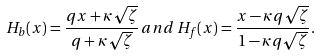Convert formula to latex. <formula><loc_0><loc_0><loc_500><loc_500>H _ { b } ( x ) = \frac { q x + \kappa \sqrt { \zeta } } { q + \kappa \sqrt { \zeta } } \, a n d \, H _ { f } ( x ) = \frac { x - \kappa q \sqrt { \zeta } } { 1 - \kappa q \sqrt { \zeta } } .</formula> 